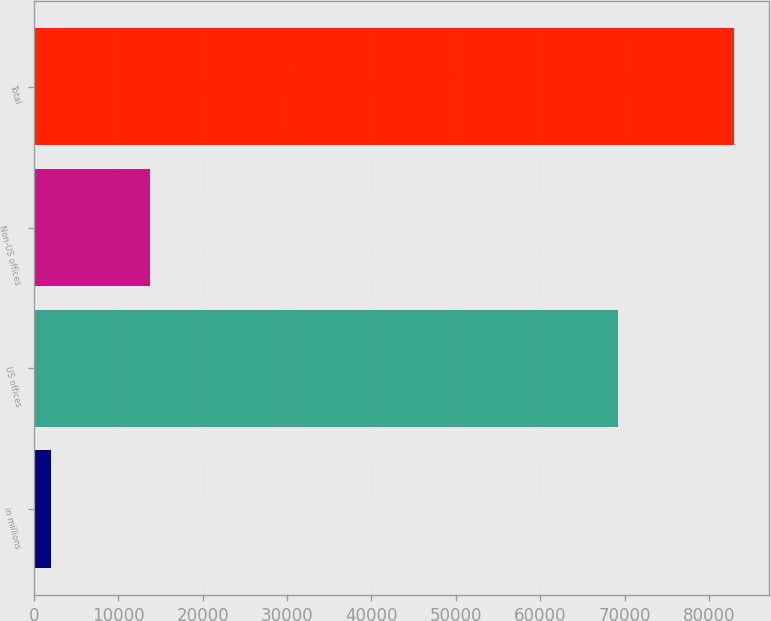<chart> <loc_0><loc_0><loc_500><loc_500><bar_chart><fcel>in millions<fcel>US offices<fcel>Non-US offices<fcel>Total<nl><fcel>2014<fcel>69270<fcel>13738<fcel>83008<nl></chart> 